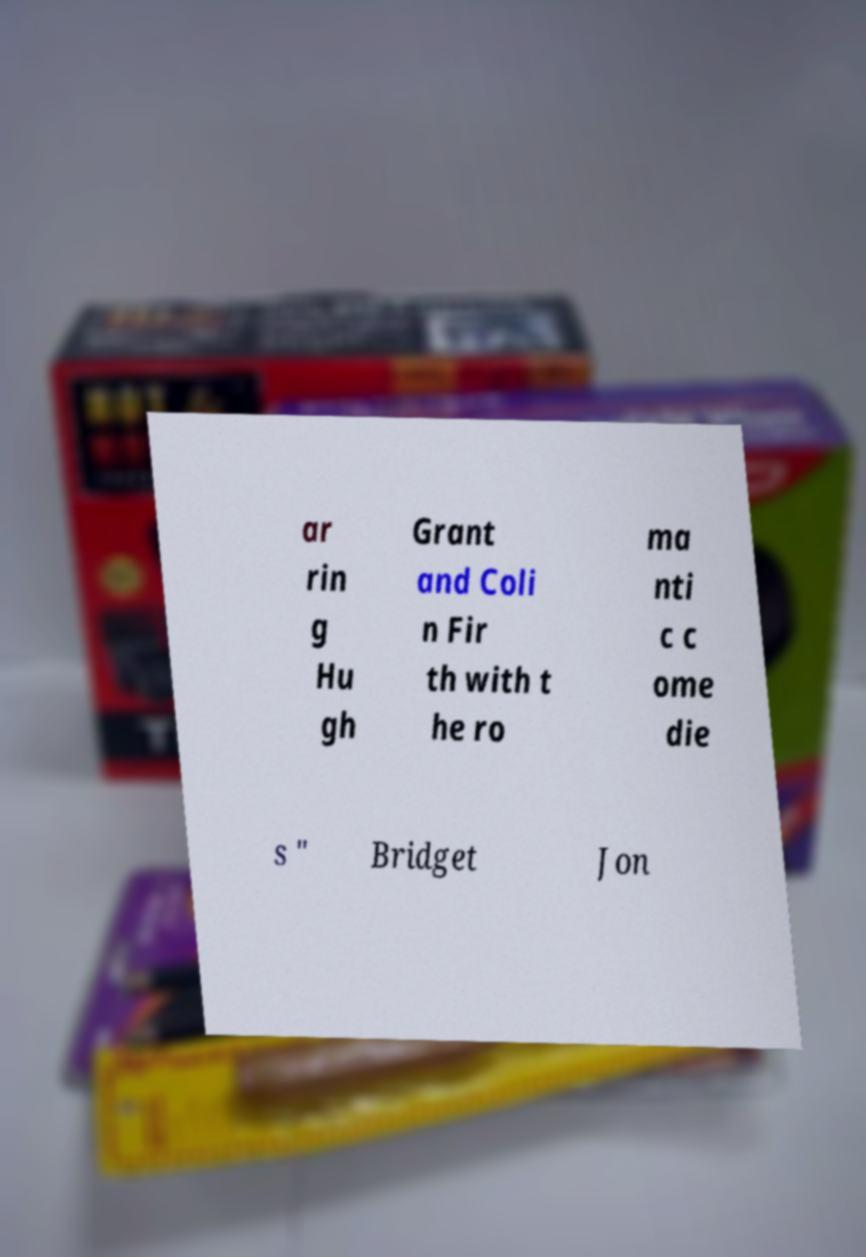What messages or text are displayed in this image? I need them in a readable, typed format. ar rin g Hu gh Grant and Coli n Fir th with t he ro ma nti c c ome die s " Bridget Jon 